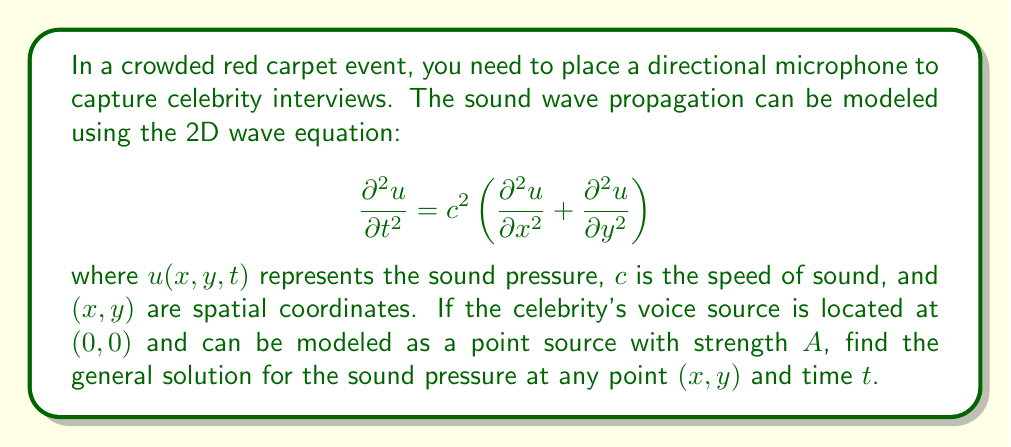Show me your answer to this math problem. To solve this problem, we'll follow these steps:

1) For a point source in 2D, we can use the Green's function solution to the wave equation. The Green's function for the 2D wave equation is:

   $$G(x,y,t) = \frac{H(ct-r)}{2\pi\sqrt{c^2t^2-r^2}}$$

   where $H$ is the Heaviside step function, $r = \sqrt{x^2+y^2}$ is the distance from the source, and $c$ is the speed of sound.

2) The general solution for a point source of strength $A$ at the origin is the convolution of the source term with the Green's function:

   $$u(x,y,t) = A \int_0^t G(x,y,t-\tau) d\tau$$

3) Substituting the Green's function and evaluating the integral:

   $$u(x,y,t) = \frac{A}{2\pi} \int_0^t \frac{H(c(t-\tau)-r)}{\sqrt{c^2(t-\tau)^2-r^2}} d\tau$$

4) The Heaviside function limits the integration to $\tau \leq t - \frac{r}{c}$, so we can change the lower limit:

   $$u(x,y,t) = \frac{A}{2\pi} \int_{t-\frac{r}{c}}^t \frac{1}{\sqrt{c^2(t-\tau)^2-r^2}} d\tau$$

5) This integral can be evaluated to give:

   $$u(x,y,t) = \frac{A}{2\pi c} \ln\left(\frac{ct+\sqrt{c^2t^2-r^2}}{r}\right)$$

This is the general solution for the sound pressure at any point $(x,y)$ and time $t$ for a point source at the origin.
Answer: $$u(x,y,t) = \frac{A}{2\pi c} \ln\left(\frac{ct+\sqrt{c^2t^2-r^2}}{r}\right)$$ 